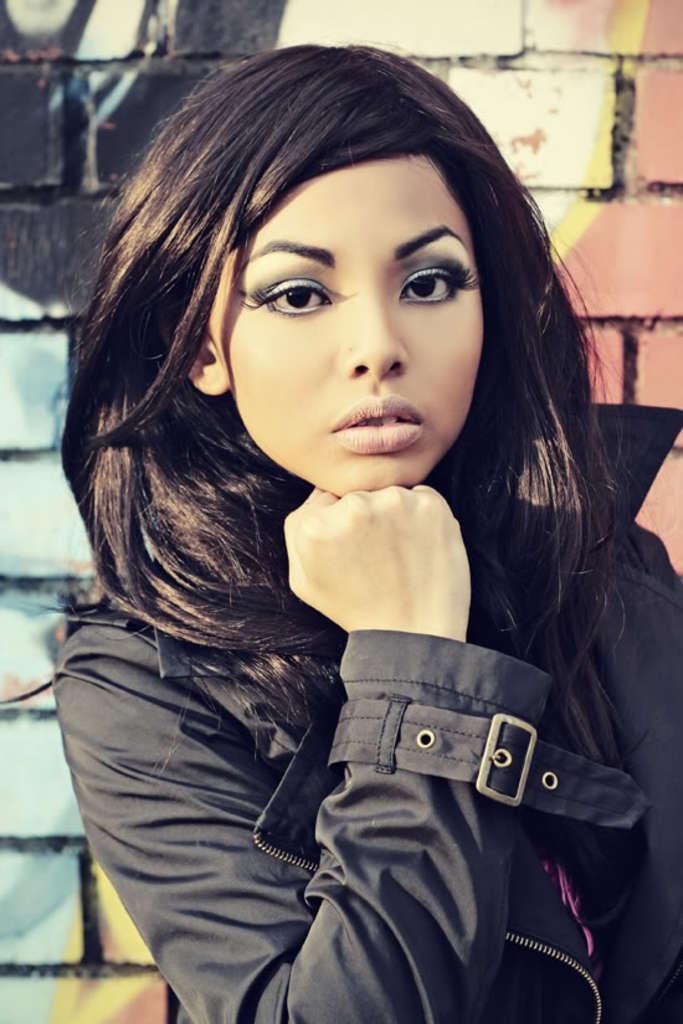How would you summarize this image in a sentence or two? In the center of the image we can see a girl standing. She is wearing a jacket. In the background there is a wall. 